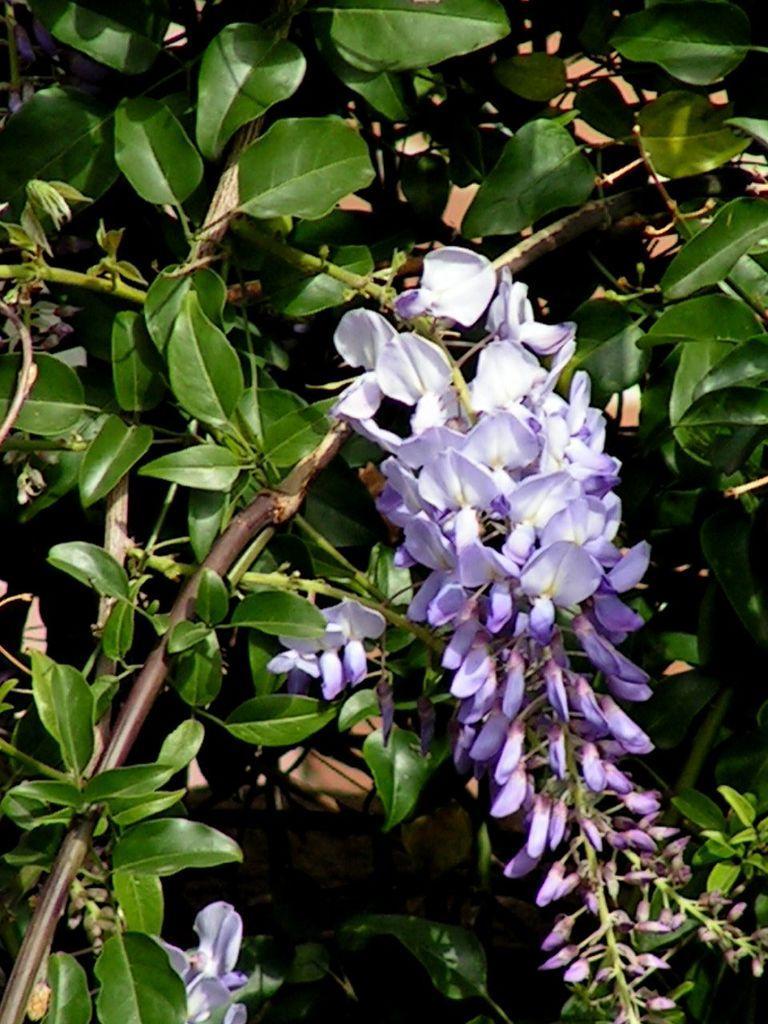Could you give a brief overview of what you see in this image? In this image we can see a plant, there are purple flowers, there is a bud. 